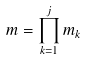<formula> <loc_0><loc_0><loc_500><loc_500>m = \prod _ { k = 1 } ^ { j } m _ { k }</formula> 